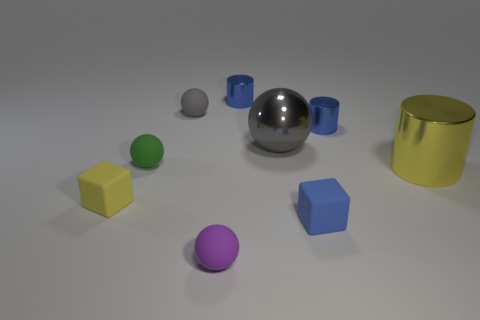There is a tiny object that is the same color as the big metallic cylinder; what shape is it?
Offer a very short reply. Cube. Is there a tiny object of the same color as the large cylinder?
Make the answer very short. Yes. There is a large ball; is its color the same as the sphere behind the large metal ball?
Provide a short and direct response. Yes. Are there fewer tiny shiny things that are on the right side of the blue matte block than tiny rubber cubes to the right of the yellow cylinder?
Your answer should be very brief. No. What is the color of the small ball that is behind the large metal cylinder and in front of the large gray shiny sphere?
Make the answer very short. Green. There is a gray metallic thing; is it the same size as the yellow object that is in front of the yellow cylinder?
Provide a short and direct response. No. The small matte thing behind the green rubber object has what shape?
Make the answer very short. Sphere. Is the number of green matte objects that are behind the big metallic cylinder greater than the number of tiny cyan metal cylinders?
Offer a terse response. Yes. There is a gray ball that is on the right side of the small matte ball that is on the right side of the gray rubber object; how many metal things are on the right side of it?
Your answer should be compact. 2. Do the matte block that is left of the small green thing and the block that is on the right side of the tiny purple object have the same size?
Make the answer very short. Yes. 